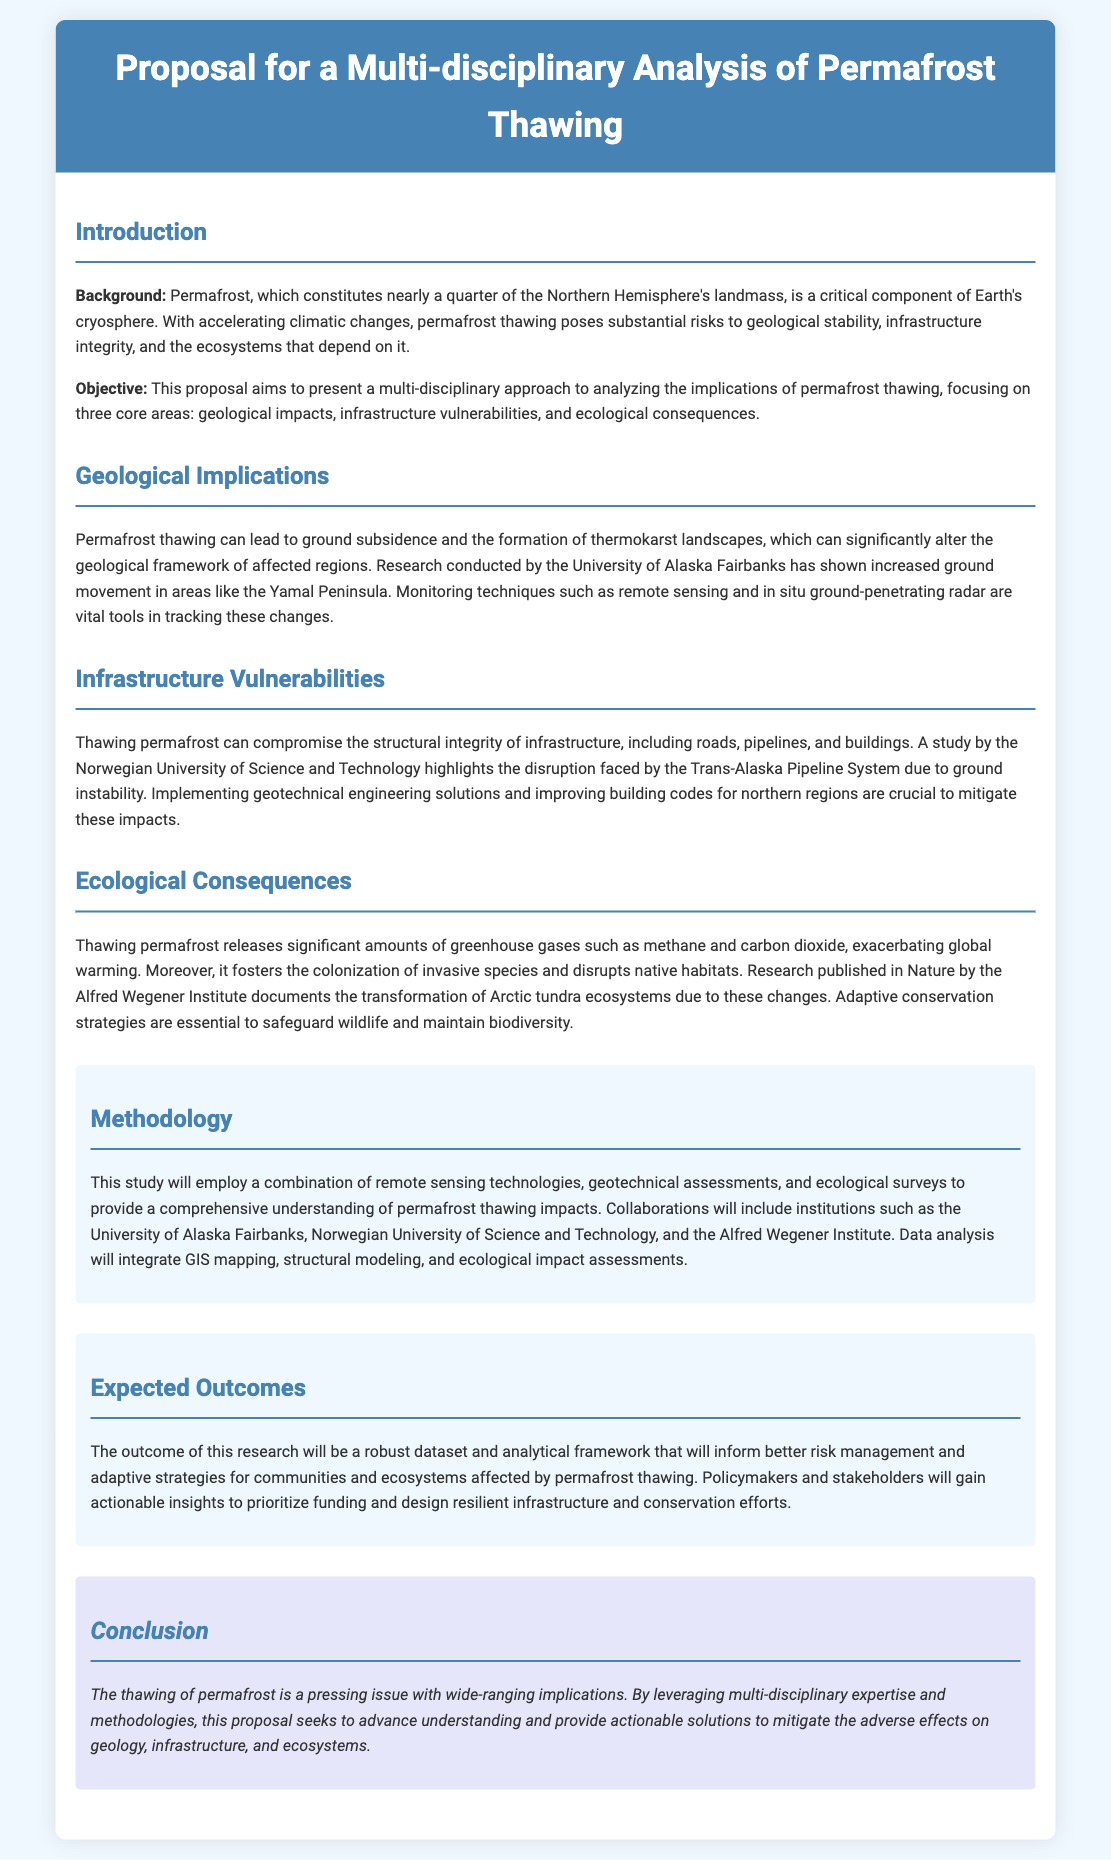What is the title of the proposal? The title of the proposal is the main heading of the document that introduces the study.
Answer: Proposal for a Multi-disciplinary Analysis of Permafrost Thawing How many core areas does the proposal focus on? The core areas mentioned in the proposal are part of the objective section.
Answer: Three Which technique is vital in tracking ground movement due to permafrost thawing? This technique is mentioned in the geological implications section as a crucial monitoring tool.
Answer: Remote sensing What specific gas is released due to permafrost thawing? This information is provided in the ecological consequences section regarding greenhouse gases.
Answer: Methane What university conducted the study on the Trans-Alaska Pipeline System? The document cites a specific university in the infrastructure vulnerabilities section.
Answer: Norwegian University of Science and Technology What type of strategies are emphasized to safeguard wildlife? This is mentioned in the ecological consequences section regarding measures to counter the impacts of thawing permafrost.
Answer: Adaptive conservation strategies What will the methodologies include for this study? This is specified in the methodology section discussing the approaches used for analysis.
Answer: Remote sensing technologies, geotechnical assessments, ecological surveys What is the overall aim of the research? The expected outcomes section discusses the main objective of the research.
Answer: Inform better risk management What does the conclusion emphasize about the thawing of permafrost? The conclusion summarizes the urgent nature of the issue discussed throughout the document.
Answer: Pressing issue with wide-ranging implications 